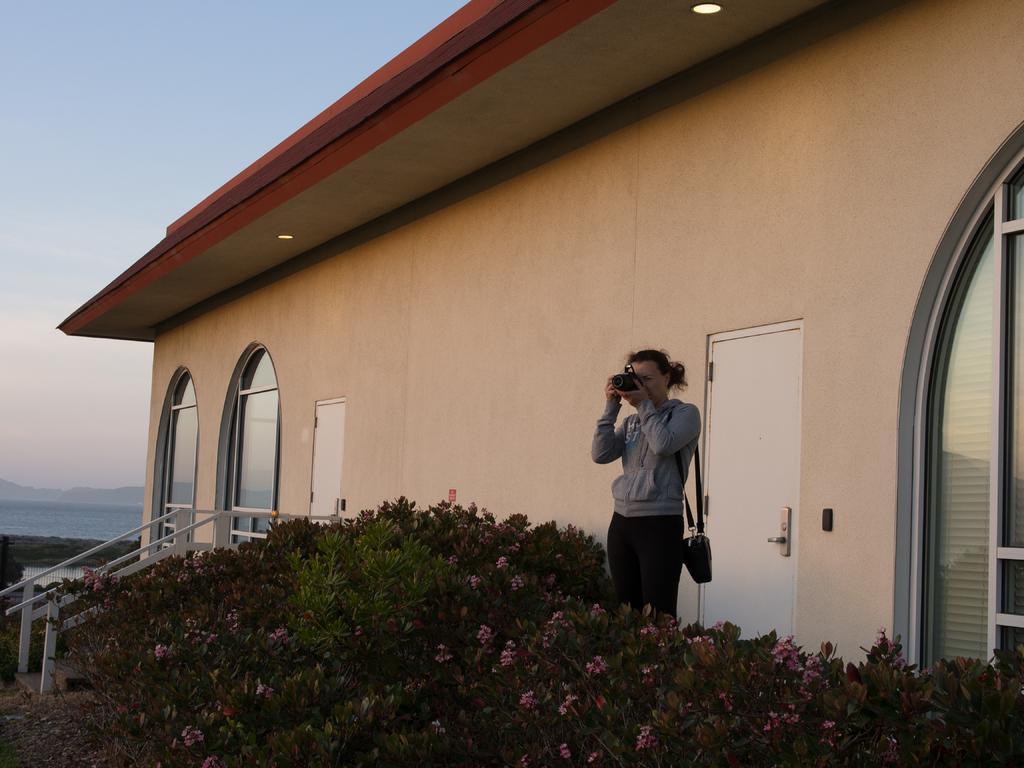Can you describe this image briefly? In this picture we can see a woman carrying a bag and holding a camera with her hands and standing, flowers, plants, house with doors and windows, wall, water, grass and in the background we can see the sky. 